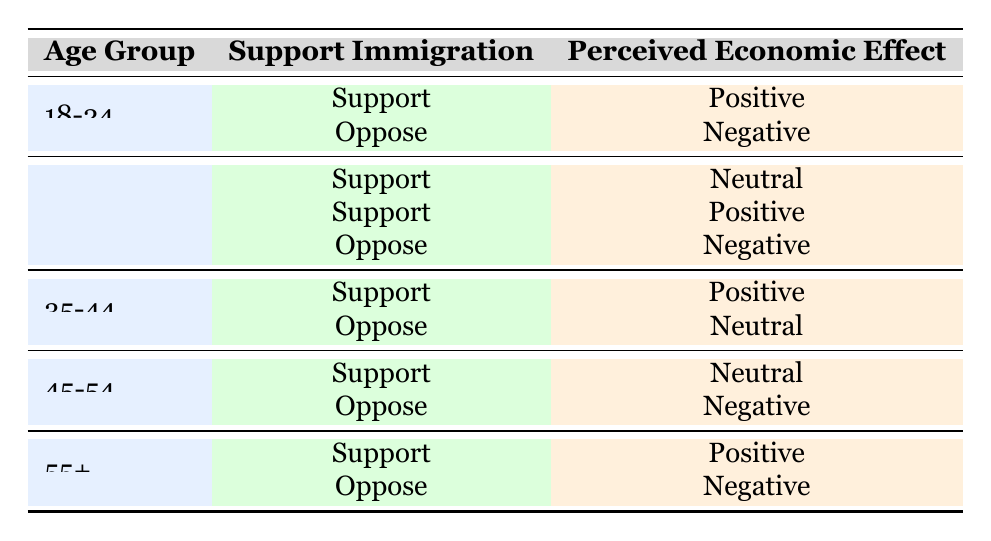What age group has the highest support for immigration with a positive perceived economic effect? Looking at the table, the age group 18-24 shows one instance of support for immigration with a positive perceived economic effect. The age groups 25-34, 35-44, and 55+ all have multiple instances of support for immigration with positive perceived economic effects, but the most frequently cited support occurs in the 55+ age group, which has two instances: both with positive perceived economic effects.
Answer: 55+ How many respondents in the age group 25-34 oppose immigration? From the table, for the age group 25-34, there is one respondent who supports immigration with neutral perceived effects, one who supports with positive perceived effects, and one respondent who opposes immigration with negative perceived effects. Thus, there is 1 instance of opposition in this age group.
Answer: 1 What is the total perceived economic effect of respondents who opposed immigration across all age groups? The table shows respondents who oppose immigration in the 18-24 group with negative, the 25-34 group with negative, the 35-44 group with neutral, the 45-54 group with negative, and the 55+ group with negative perceived effects. The total perceived economic effect for opponents is: negative (1) + negative (1) + neutral (0) + negative (1) + negative (1) = 4 negative instances.
Answer: 4 Is there any age group that supports immigration and has a neutral perceived economic effect? According to the table, the age group 25-34 has one instance where support for immigration coincides with a neutral perceived economic effect.
Answer: Yes Which age group has the highest count of respondents supporting immigration overall? Referring to the table, the age group 25-34 has two instances of support (one positive, one neutral), age group 35-44 has one instance of support (positive), age group 45-54 has one instance (neutral), and age group 55+ has one instance (positive). Therefore, the age group 25-34 has the highest count of respondents supporting immigration overall.
Answer: 25-34 What percentage of respondents in the age group 45-54 oppose immigration? The age group 45-54 has two instances: one instance of support (neutral) and one instance of opposition (negative). With only one instance of opposition out of two total responses, the percentage of opposition is (1/2)*100 = 50%.
Answer: 50% 